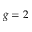Convert formula to latex. <formula><loc_0><loc_0><loc_500><loc_500>g = 2</formula> 